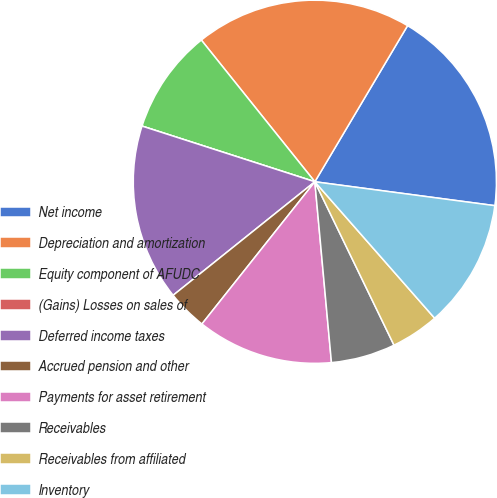Convert chart. <chart><loc_0><loc_0><loc_500><loc_500><pie_chart><fcel>Net income<fcel>Depreciation and amortization<fcel>Equity component of AFUDC<fcel>(Gains) Losses on sales of<fcel>Deferred income taxes<fcel>Accrued pension and other<fcel>Payments for asset retirement<fcel>Receivables<fcel>Receivables from affiliated<fcel>Inventory<nl><fcel>18.57%<fcel>19.28%<fcel>9.29%<fcel>0.0%<fcel>15.71%<fcel>3.57%<fcel>12.14%<fcel>5.72%<fcel>4.29%<fcel>11.43%<nl></chart> 